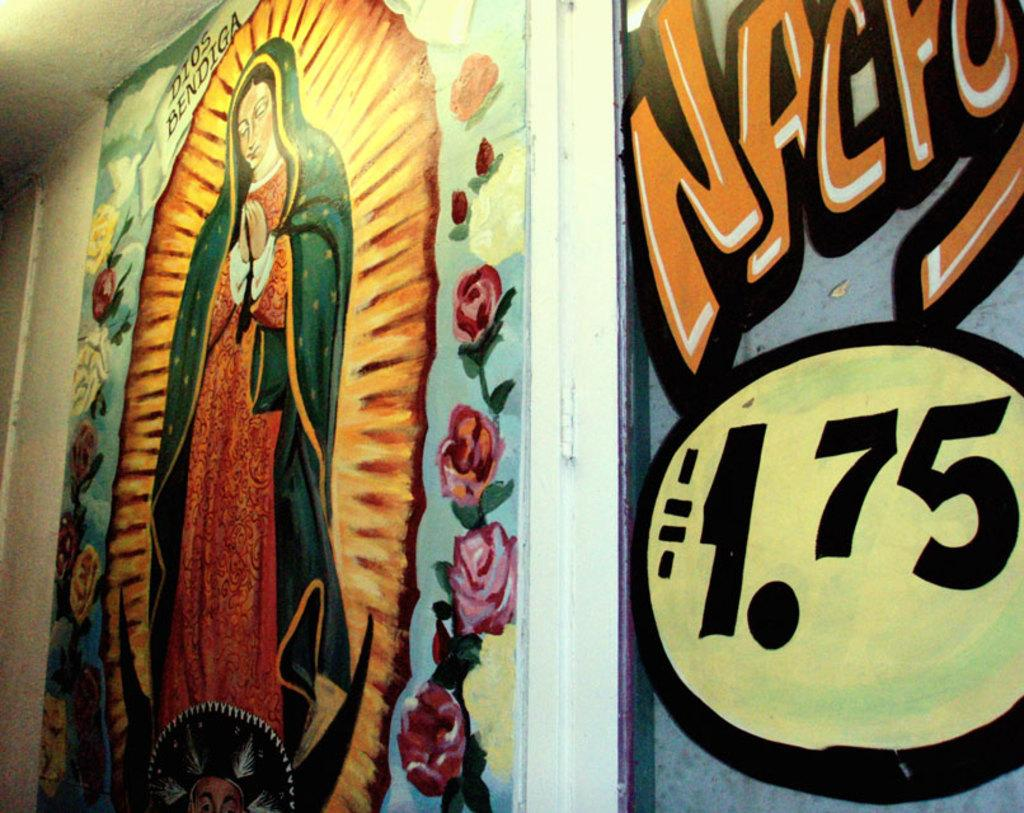What is depicted on the left side of the image? There is a painting of a lady on the left side of the image. Where is the painting of the lady located? The painting of the lady is on a wall. What is depicted on the right side of the image? There is a painting of some text on the right side of the image. Where is the painting of the text located? The painting of the text is also on a wall. What type of hole can be seen in the painting of the lady? There is no hole present in the painting of the lady; it is a flat, two-dimensional image. 